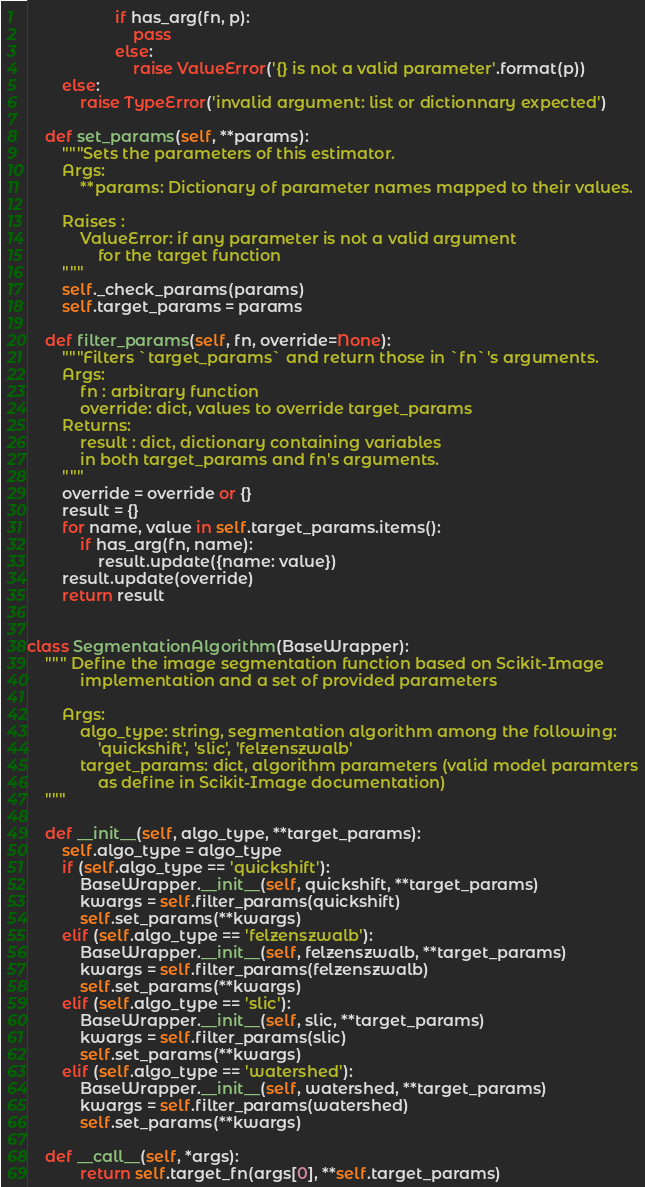Convert code to text. <code><loc_0><loc_0><loc_500><loc_500><_Python_>                    if has_arg(fn, p):
                        pass
                    else:
                        raise ValueError('{} is not a valid parameter'.format(p))
        else:
            raise TypeError('invalid argument: list or dictionnary expected')

    def set_params(self, **params):
        """Sets the parameters of this estimator.
        Args:
            **params: Dictionary of parameter names mapped to their values.

        Raises :
            ValueError: if any parameter is not a valid argument
                for the target function
        """
        self._check_params(params)
        self.target_params = params

    def filter_params(self, fn, override=None):
        """Filters `target_params` and return those in `fn`'s arguments.
        Args:
            fn : arbitrary function
            override: dict, values to override target_params
        Returns:
            result : dict, dictionary containing variables
            in both target_params and fn's arguments.
        """
        override = override or {}
        result = {}
        for name, value in self.target_params.items():
            if has_arg(fn, name):
                result.update({name: value})
        result.update(override)
        return result


class SegmentationAlgorithm(BaseWrapper):
    """ Define the image segmentation function based on Scikit-Image
            implementation and a set of provided parameters

        Args:
            algo_type: string, segmentation algorithm among the following:
                'quickshift', 'slic', 'felzenszwalb'
            target_params: dict, algorithm parameters (valid model paramters
                as define in Scikit-Image documentation)
    """

    def __init__(self, algo_type, **target_params):
        self.algo_type = algo_type
        if (self.algo_type == 'quickshift'):
            BaseWrapper.__init__(self, quickshift, **target_params)
            kwargs = self.filter_params(quickshift)
            self.set_params(**kwargs)
        elif (self.algo_type == 'felzenszwalb'):
            BaseWrapper.__init__(self, felzenszwalb, **target_params)
            kwargs = self.filter_params(felzenszwalb)
            self.set_params(**kwargs)
        elif (self.algo_type == 'slic'):
            BaseWrapper.__init__(self, slic, **target_params)
            kwargs = self.filter_params(slic)
            self.set_params(**kwargs)
        elif (self.algo_type == 'watershed'):
            BaseWrapper.__init__(self, watershed, **target_params)
            kwargs = self.filter_params(watershed)
            self.set_params(**kwargs)

    def __call__(self, *args):
            return self.target_fn(args[0], **self.target_params)
</code> 